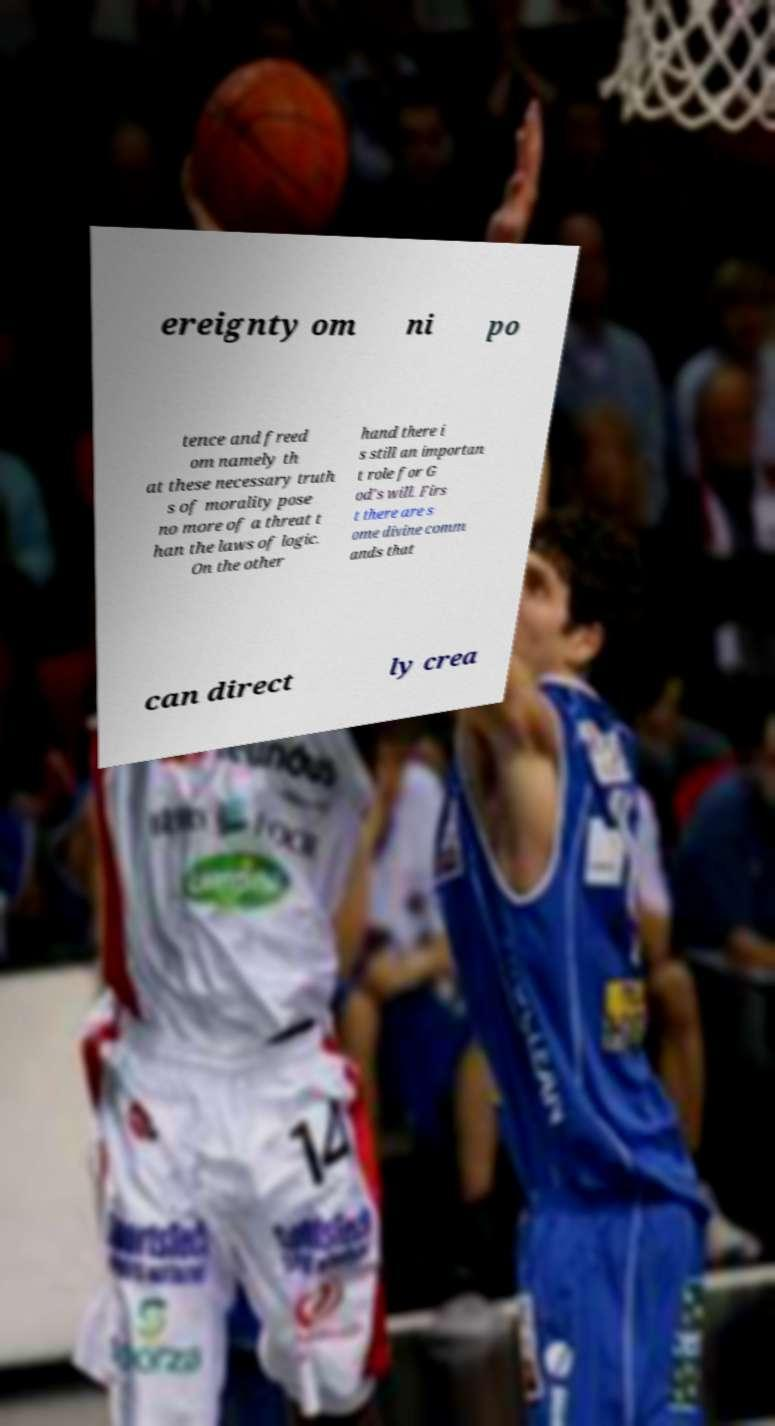There's text embedded in this image that I need extracted. Can you transcribe it verbatim? ereignty om ni po tence and freed om namely th at these necessary truth s of morality pose no more of a threat t han the laws of logic. On the other hand there i s still an importan t role for G od's will. Firs t there are s ome divine comm ands that can direct ly crea 